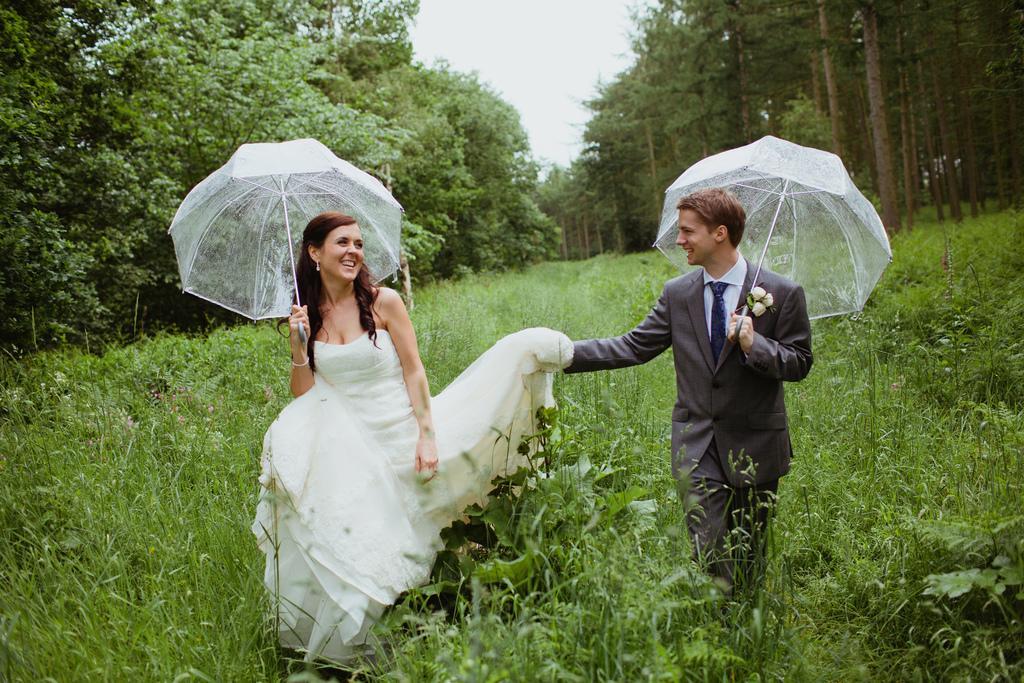Describe this image in one or two sentences. In this picture we can see a man and woman, the are holding an umbrella and they both are smiling, in the background we can see plants and trees. 